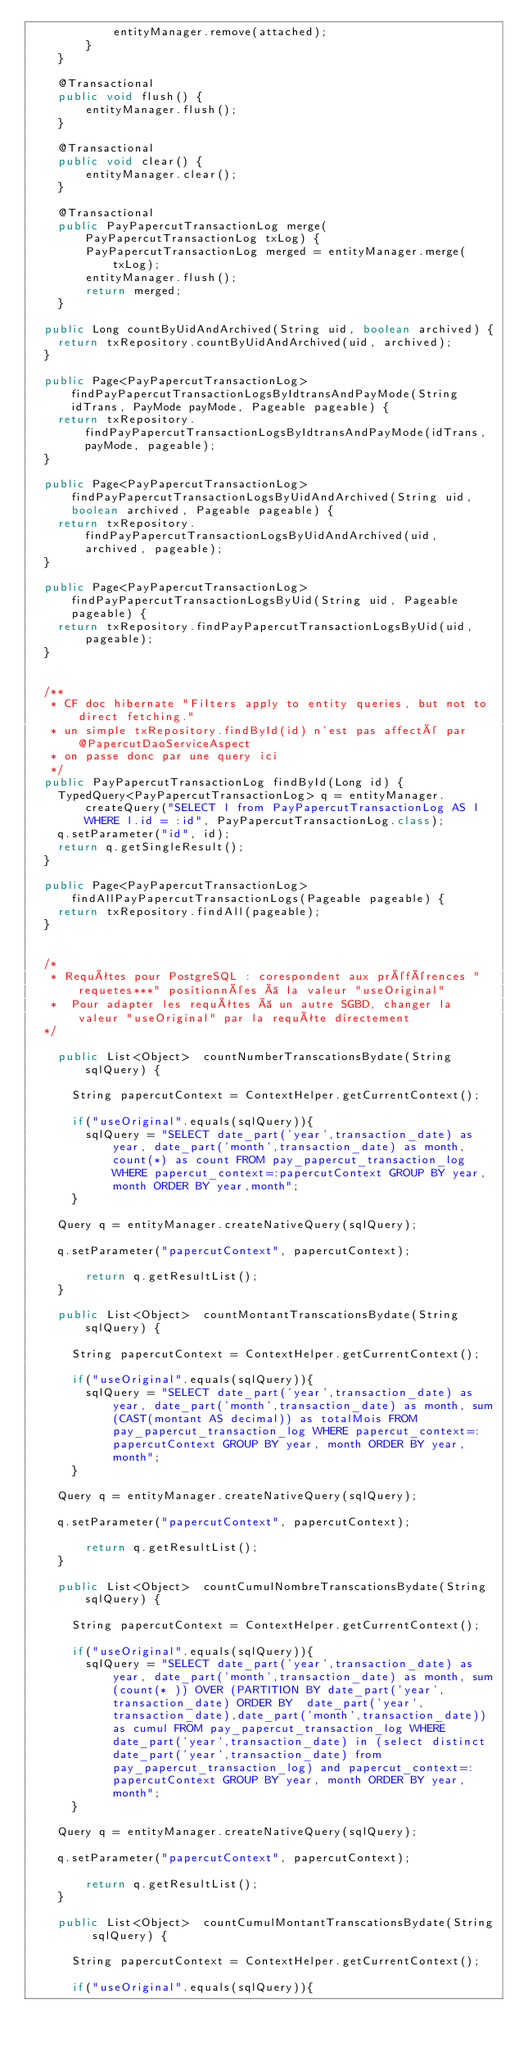Convert code to text. <code><loc_0><loc_0><loc_500><loc_500><_Java_>            entityManager.remove(attached);
        }
    }
    
    @Transactional
    public void flush() {       
        entityManager.flush();
    }
    
    @Transactional
    public void clear() {        
        entityManager.clear();
    }
    
    @Transactional
    public PayPapercutTransactionLog merge(PayPapercutTransactionLog txLog) {        
        PayPapercutTransactionLog merged = entityManager.merge(txLog);
        entityManager.flush();
        return merged;
    }
    
	public Long countByUidAndArchived(String uid, boolean archived) {
		return txRepository.countByUidAndArchived(uid, archived);
	}

	public Page<PayPapercutTransactionLog> findPayPapercutTransactionLogsByIdtransAndPayMode(String idTrans, PayMode payMode, Pageable pageable) {
		return txRepository.findPayPapercutTransactionLogsByIdtransAndPayMode(idTrans, payMode, pageable);
	}

	public Page<PayPapercutTransactionLog> findPayPapercutTransactionLogsByUidAndArchived(String uid, boolean archived, Pageable pageable) {
		return txRepository.findPayPapercutTransactionLogsByUidAndArchived(uid, archived, pageable);
	}

	public Page<PayPapercutTransactionLog> findPayPapercutTransactionLogsByUid(String uid, Pageable pageable) {
		return txRepository.findPayPapercutTransactionLogsByUid(uid, pageable);
	}

	
	/**
	 * CF doc hibernate "Filters apply to entity queries, but not to direct fetching."
	 * un simple txRepository.findById(id) n'est pas affecté par @PapercutDaoServiceAspect
	 * on passe donc par une query ici
	 */
	public PayPapercutTransactionLog findById(Long id) {
		TypedQuery<PayPapercutTransactionLog> q = entityManager.createQuery("SELECT l from PayPapercutTransactionLog AS l WHERE l.id = :id", PayPapercutTransactionLog.class);
		q.setParameter("id", id);
		return q.getSingleResult();
	}

	public Page<PayPapercutTransactionLog> findAllPayPapercutTransactionLogs(Pageable pageable) {
		return txRepository.findAll(pageable);
	}
    
	
	/*
	 * Requêtes pour PostgreSQL : corespondent aux préférences "requetes***" positionnées à la valeur "useOriginal"
	 * 	Pour adapter les requêtes à un autre SGBD, changer la valeur "useOriginal" par la requête directement
	*/
	
    public List<Object>  countNumberTranscationsBydate(String sqlQuery) {
    	
    	String papercutContext = ContextHelper.getCurrentContext();
    	
    	if("useOriginal".equals(sqlQuery)){
    		sqlQuery = "SELECT date_part('year',transaction_date) as year, date_part('month',transaction_date) as month, count(*) as count FROM pay_papercut_transaction_log WHERE papercut_context=:papercutContext GROUP BY year, month ORDER BY year,month";
    	}

		Query q = entityManager.createNativeQuery(sqlQuery);
		
		q.setParameter("papercutContext", papercutContext);

        return q.getResultList();
    }
    
    public List<Object>  countMontantTranscationsBydate(String sqlQuery) {
    	
    	String papercutContext = ContextHelper.getCurrentContext();
    	
    	if("useOriginal".equals(sqlQuery)){
    		sqlQuery = "SELECT date_part('year',transaction_date) as year, date_part('month',transaction_date) as month, sum(CAST(montant AS decimal)) as totalMois FROM pay_papercut_transaction_log WHERE papercut_context=:papercutContext GROUP BY year, month ORDER BY year,month";
    	}

		Query q = entityManager.createNativeQuery(sqlQuery);
		
		q.setParameter("papercutContext", papercutContext);

        return q.getResultList();
    }
    
    public List<Object>  countCumulNombreTranscationsBydate(String sqlQuery) {
    	
    	String papercutContext = ContextHelper.getCurrentContext();
    	
    	if("useOriginal".equals(sqlQuery)){
    		sqlQuery = "SELECT date_part('year',transaction_date) as year, date_part('month',transaction_date) as month, sum(count(* )) OVER (PARTITION BY date_part('year',transaction_date) ORDER BY  date_part('year',transaction_date),date_part('month',transaction_date)) as cumul FROM pay_papercut_transaction_log WHERE date_part('year',transaction_date) in (select distinct date_part('year',transaction_date) from pay_papercut_transaction_log) and papercut_context=:papercutContext GROUP BY year, month ORDER BY year,month";
    	}

		Query q = entityManager.createNativeQuery(sqlQuery);
		
		q.setParameter("papercutContext", papercutContext);

        return q.getResultList();
    }
    
    public List<Object>  countCumulMontantTranscationsBydate(String sqlQuery) {
    	
    	String papercutContext = ContextHelper.getCurrentContext();
    	
    	if("useOriginal".equals(sqlQuery)){</code> 